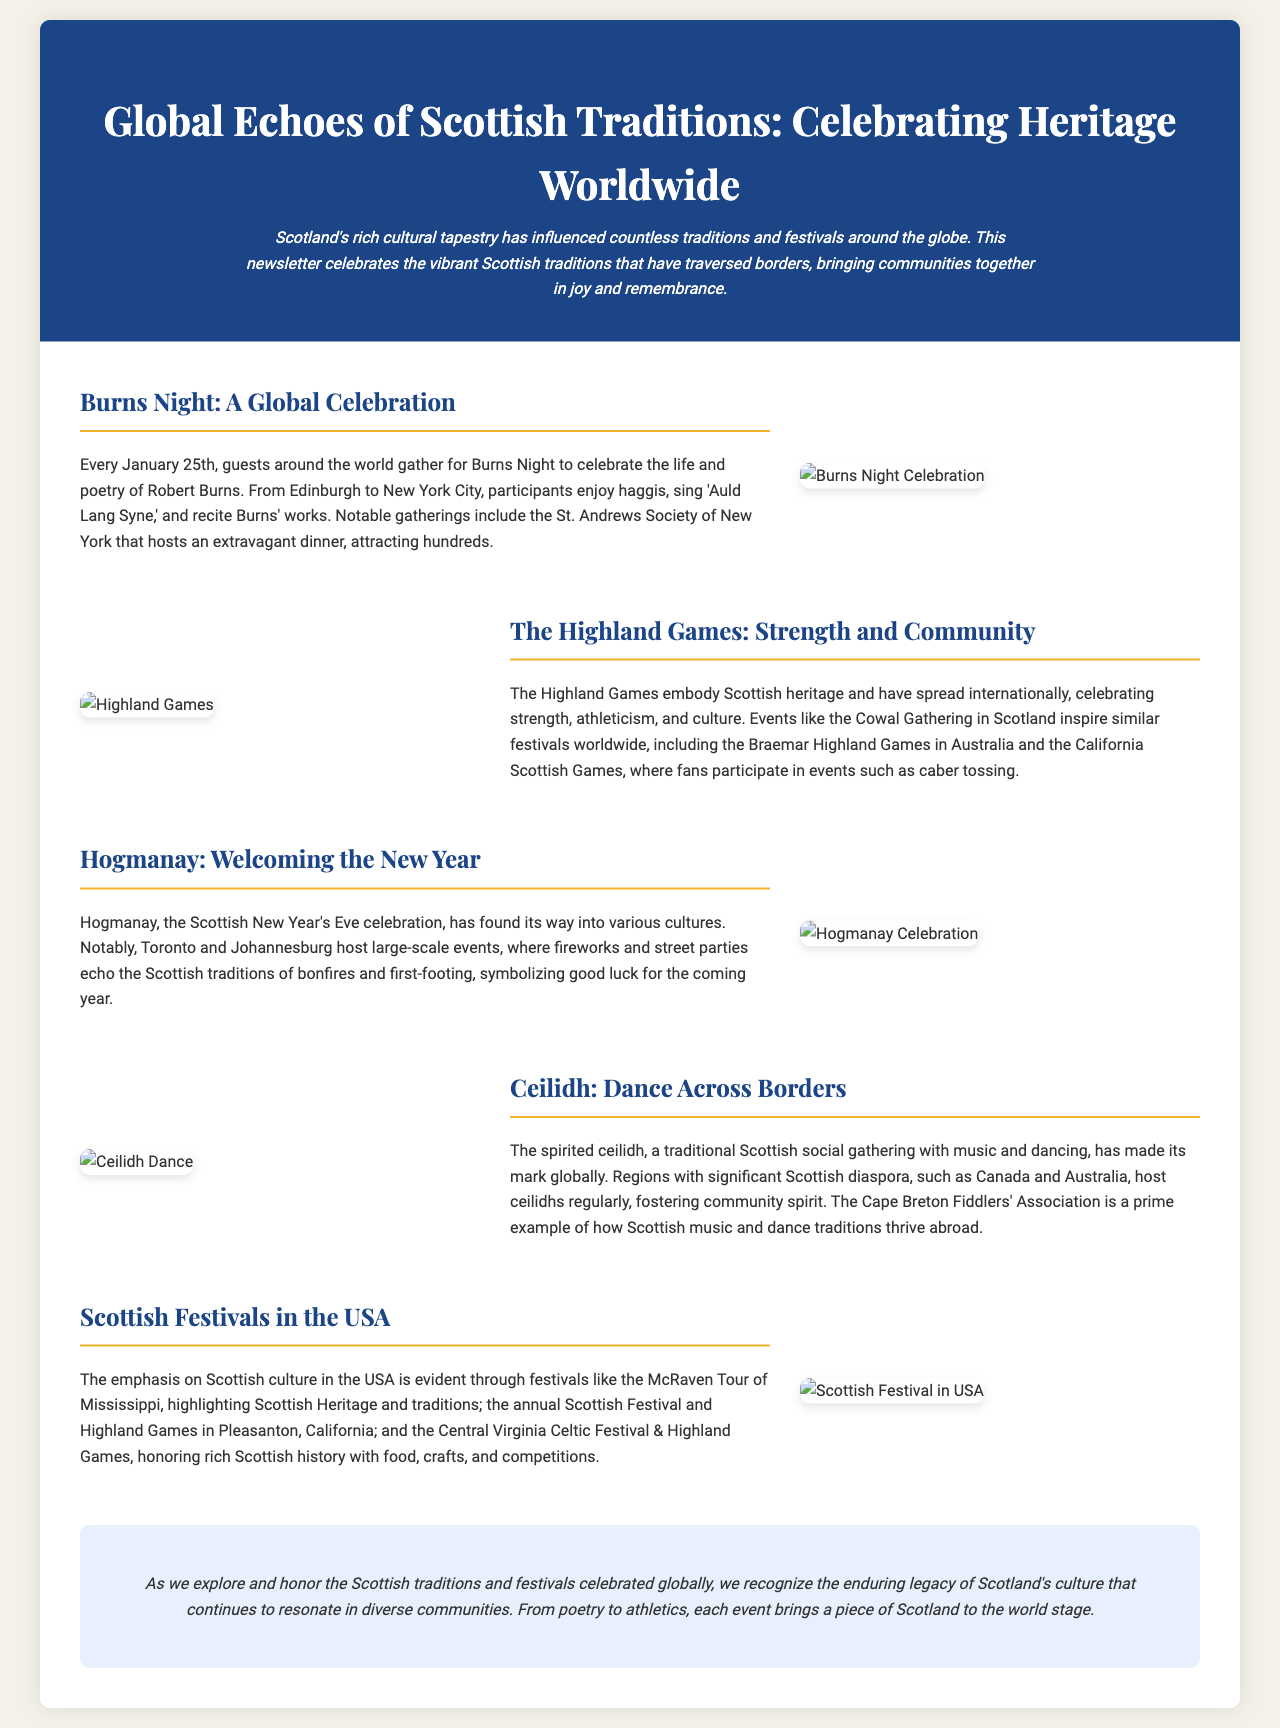What date is celebrated for Burns Night? The document mentions that Burns Night is celebrated every January 25th.
Answer: January 25th Which city is mentioned as hosting an extravagant Burns Night dinner? The St. Andrews Society of New York is highlighted in the document as hosting a notable Burns Night dinner.
Answer: New York City What sport is included in the Highland Games? The document lists various competitions held at the Highland Games, including caber tossing.
Answer: Caber tossing What type of gathering is a ceilidh? The document describes a ceilidh as a traditional Scottish social gathering with music and dancing.
Answer: Social gathering Which two cities are noted for hosting large-scale Hogmanay events? The document specifies Toronto and Johannesburg as cities that hold large-scale Hogmanay celebrations.
Answer: Toronto and Johannesburg What is a common theme found in Scottish festivals celebrated in the USA? The document states that the festivals honor rich Scottish history with food, crafts, and competitions, a common theme throughout the various celebrations.
Answer: Rich Scottish history What is the overall theme of the newsletter? The newsletter celebrates the global influence of Scottish traditions and festivals, emphasizing their cultural impact.
Answer: Global influence of Scottish traditions How often do ceilidhs occur in regions with a Scottish diaspora? The document implies that ceilidhs are hosted regularly in areas with significant Scottish heritage, suggesting frequent occurrences.
Answer: Regularly 